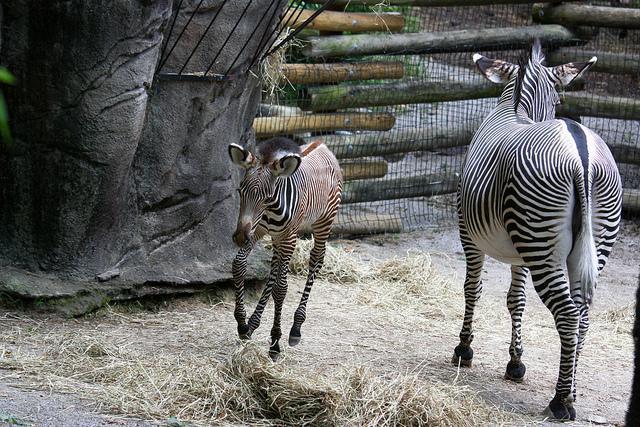How many zebras?
Give a very brief answer. 2. How many zebras are visible?
Give a very brief answer. 2. How many people have on red hats?
Give a very brief answer. 0. 